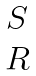<formula> <loc_0><loc_0><loc_500><loc_500>\begin{matrix} S \\ R \end{matrix}</formula> 